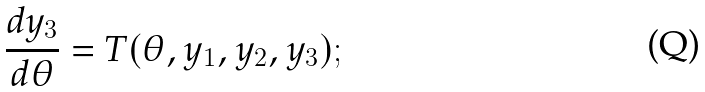<formula> <loc_0><loc_0><loc_500><loc_500>\frac { d y _ { 3 } } { d \theta } = T ( \theta , y _ { 1 } , y _ { 2 } , y _ { 3 } ) ;</formula> 